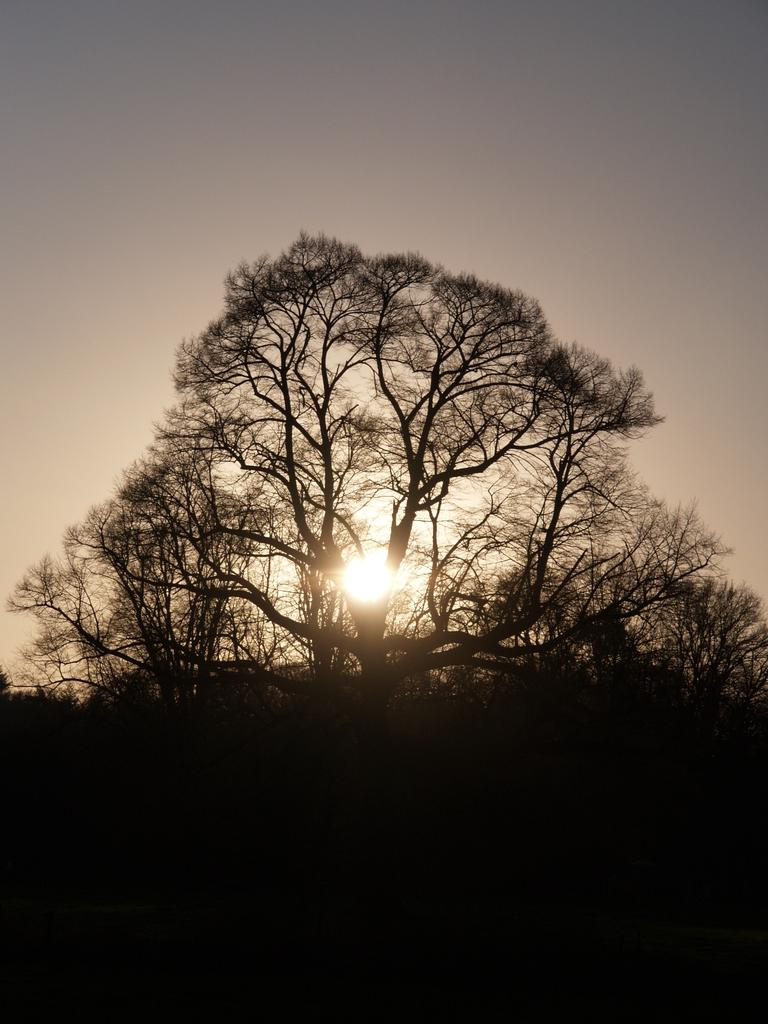What can be seen in the sky in the image? The sky is visible in the image. What celestial body is observable in the sky? The sun is observable in the image. What type of vegetation is present in the image? There are trees in the image. How much money is being exchanged between the trees in the image? There is no money being exchanged between the trees in the image, as trees are not capable of exchanging money. 